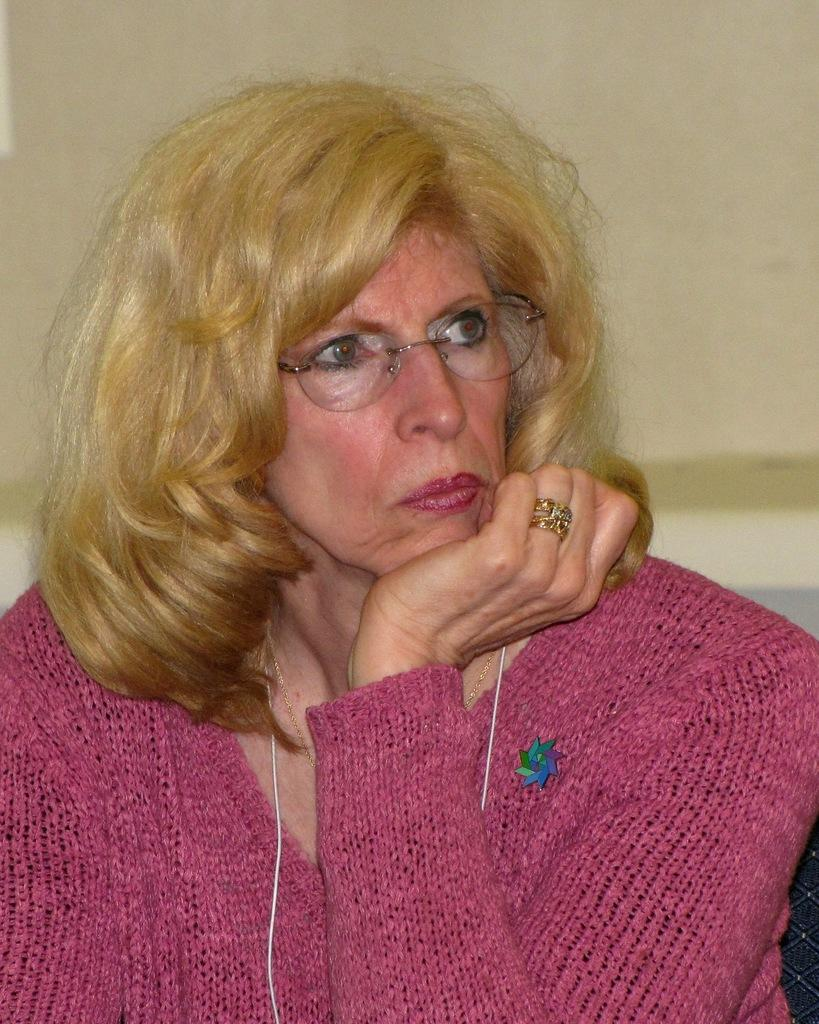Who is the main subject in the image? There is a woman in the center of the image. What can be seen behind the woman? There is a wall in the background of the image. What type of star is visible on the woman's wrist in the image? There is no star visible on the woman's wrist in the image. What is the woman using to eat in the image? There is no fork or any eating utensil present in the image. 